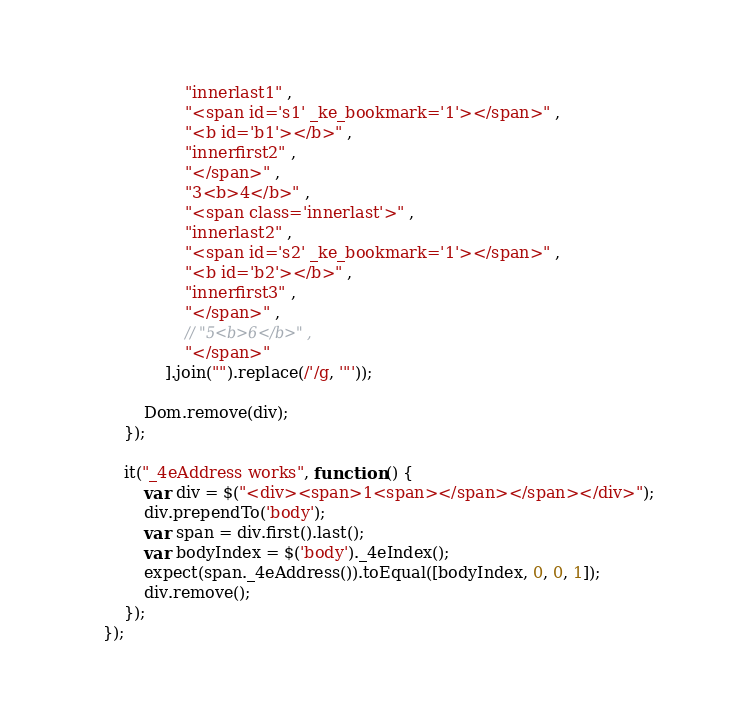<code> <loc_0><loc_0><loc_500><loc_500><_JavaScript_>                    "innerlast1" ,
                    "<span id='s1' _ke_bookmark='1'></span>" ,
                    "<b id='b1'></b>" ,
                    "innerfirst2" ,
                    "</span>" ,
                    "3<b>4</b>" ,
                    "<span class='innerlast'>" ,
                    "innerlast2" ,
                    "<span id='s2' _ke_bookmark='1'></span>" ,
                    "<b id='b2'></b>" ,
                    "innerfirst3" ,
                    "</span>" ,
                    // "5<b>6</b>" ,
                    "</span>"
                ].join("").replace(/'/g, '"'));

            Dom.remove(div);
        });

        it("_4eAddress works", function () {
            var div = $("<div><span>1<span></span></span></div>");
            div.prependTo('body');
            var span = div.first().last();
            var bodyIndex = $('body')._4eIndex();
            expect(span._4eAddress()).toEqual([bodyIndex, 0, 0, 1]);
            div.remove();
        });
    });</code> 